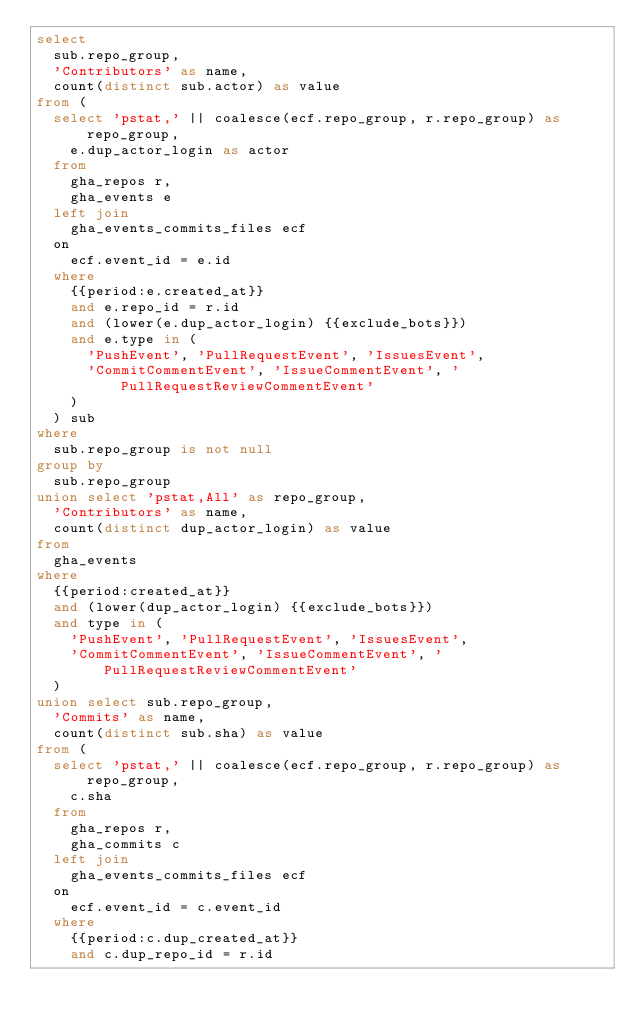Convert code to text. <code><loc_0><loc_0><loc_500><loc_500><_SQL_>select
  sub.repo_group,
  'Contributors' as name,
  count(distinct sub.actor) as value
from (
  select 'pstat,' || coalesce(ecf.repo_group, r.repo_group) as repo_group,
    e.dup_actor_login as actor
  from
    gha_repos r,
    gha_events e
  left join
    gha_events_commits_files ecf
  on
    ecf.event_id = e.id
  where
    {{period:e.created_at}}
    and e.repo_id = r.id
    and (lower(e.dup_actor_login) {{exclude_bots}})
    and e.type in (
      'PushEvent', 'PullRequestEvent', 'IssuesEvent',
      'CommitCommentEvent', 'IssueCommentEvent', 'PullRequestReviewCommentEvent'
    )
  ) sub
where
  sub.repo_group is not null
group by
  sub.repo_group
union select 'pstat,All' as repo_group,
  'Contributors' as name,
  count(distinct dup_actor_login) as value
from
  gha_events
where
  {{period:created_at}}
  and (lower(dup_actor_login) {{exclude_bots}})
  and type in (
    'PushEvent', 'PullRequestEvent', 'IssuesEvent',
    'CommitCommentEvent', 'IssueCommentEvent', 'PullRequestReviewCommentEvent'
  )
union select sub.repo_group,
  'Commits' as name,
  count(distinct sub.sha) as value
from (
  select 'pstat,' || coalesce(ecf.repo_group, r.repo_group) as repo_group,
    c.sha
  from
    gha_repos r,
    gha_commits c
  left join
    gha_events_commits_files ecf
  on
    ecf.event_id = c.event_id
  where
    {{period:c.dup_created_at}}
    and c.dup_repo_id = r.id</code> 